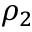<formula> <loc_0><loc_0><loc_500><loc_500>\rho _ { 2 }</formula> 